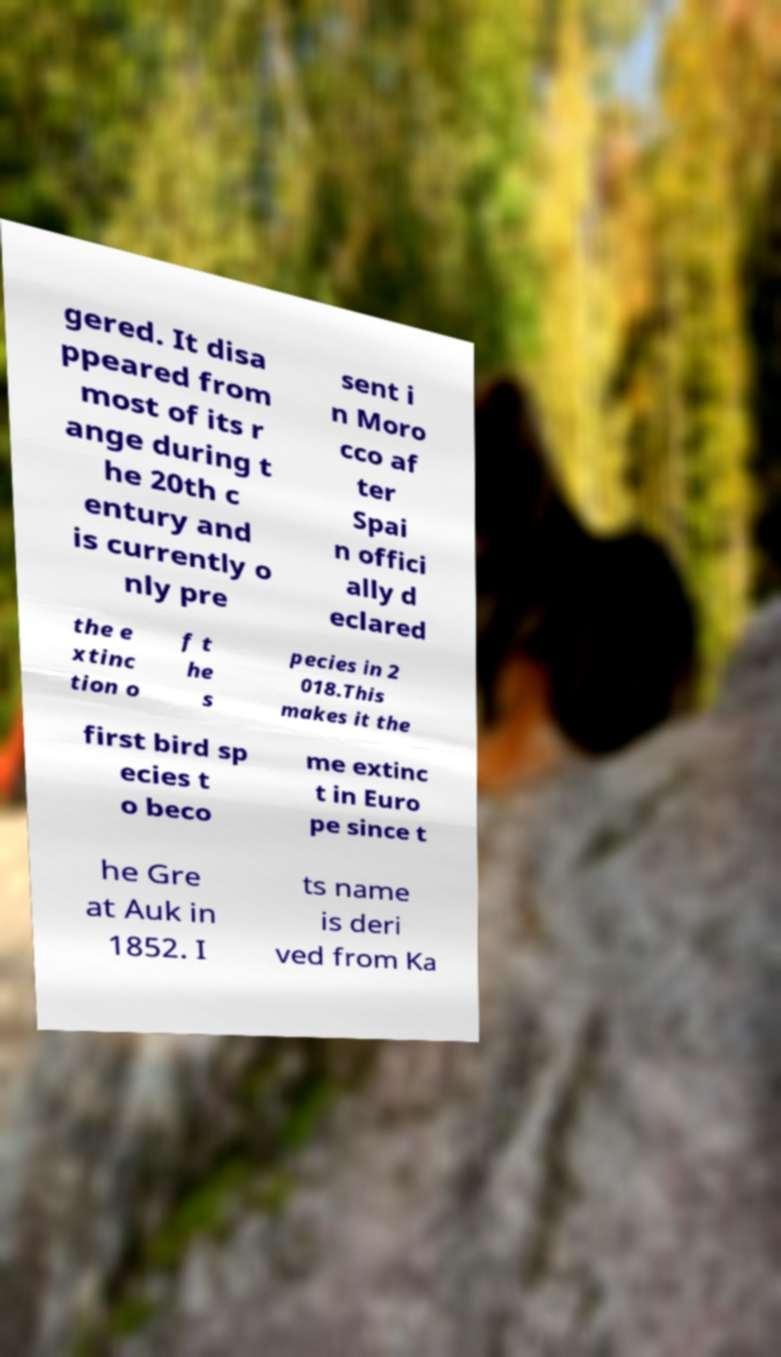There's text embedded in this image that I need extracted. Can you transcribe it verbatim? gered. It disa ppeared from most of its r ange during t he 20th c entury and is currently o nly pre sent i n Moro cco af ter Spai n offici ally d eclared the e xtinc tion o f t he s pecies in 2 018.This makes it the first bird sp ecies t o beco me extinc t in Euro pe since t he Gre at Auk in 1852. I ts name is deri ved from Ka 